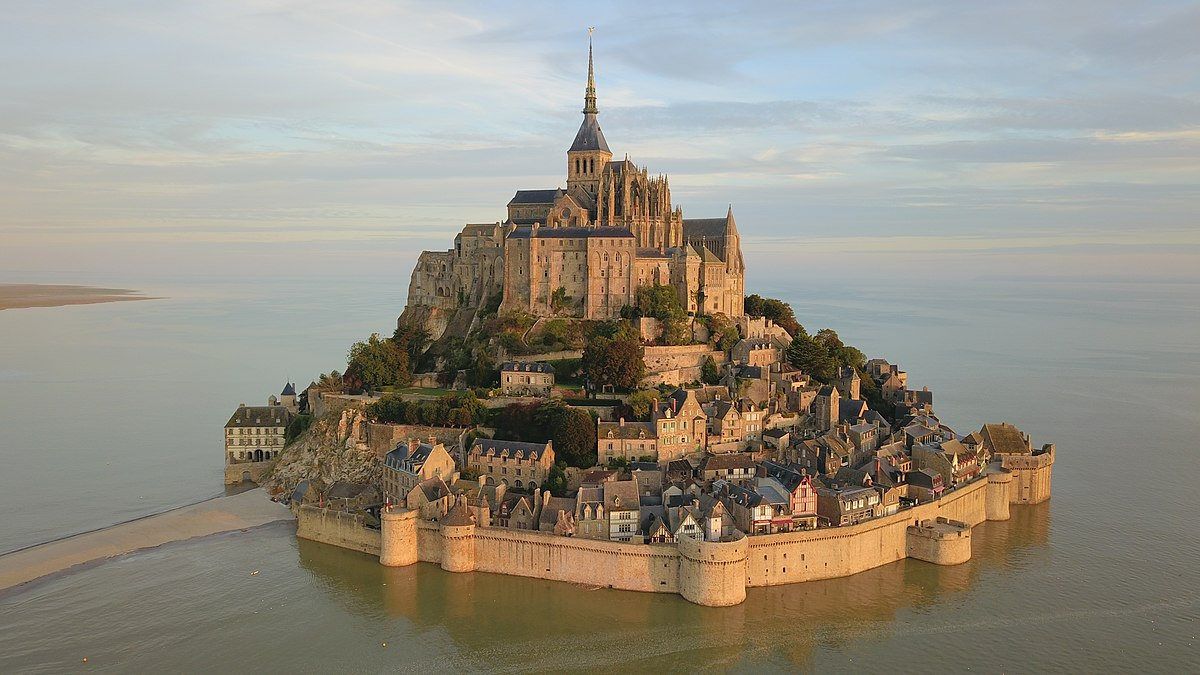What's happening in the scene? This image showcases an aerial view of Mont St Michel, an iconic island commune located in Normandy, France. The island is majestically situated amidst the shimmering blue waters and is connected to the mainland by a causeway. The focal point of the scene is the impressive Gothic abbey, which boasts a tall spire that reaches toward the sky. Surrounding the abbey is a fortified wall, adding a sense of security and historical grandeur. Nestled within these fortifications is a charming village characterized by stone buildings and narrow, winding streets that create an intricate labyrinth. The architectural palette is predominantly beige and gray, reflecting the historic stone structures, with splashes of greenery providing a natural contrast. The perspective from above grants a comprehensive view, highlighting the strategic location and magnificent architecture of this renowned landmark. The overall composition of the image captures the timeless beauty and historical significance of Mont St Michel. 